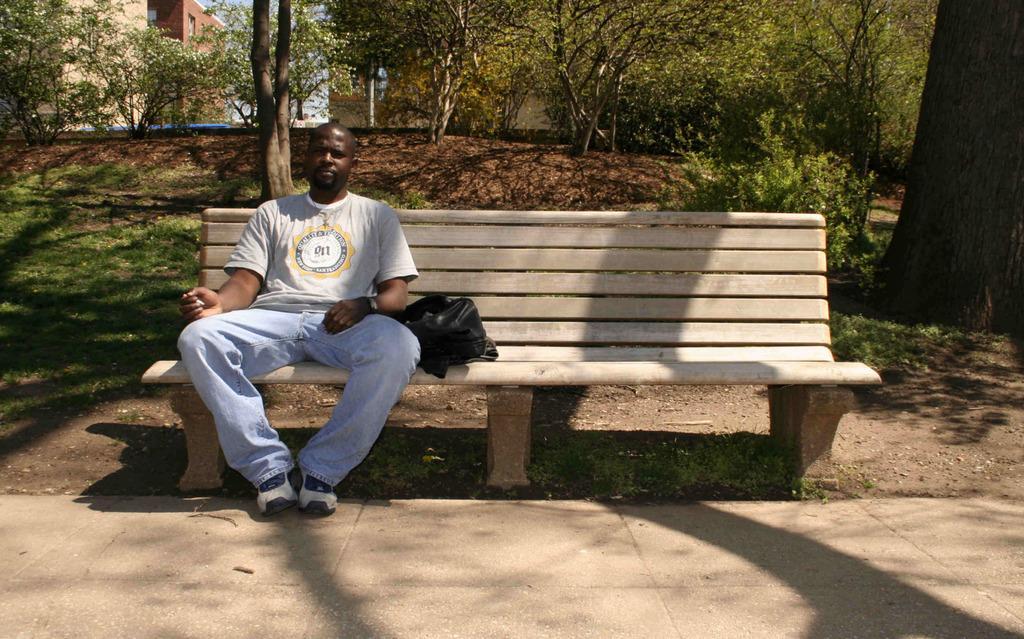Can you describe this image briefly? In this image i can see a man sitting on a bench and a bag beside him. In the background i can see buildings, trees and the sky. 